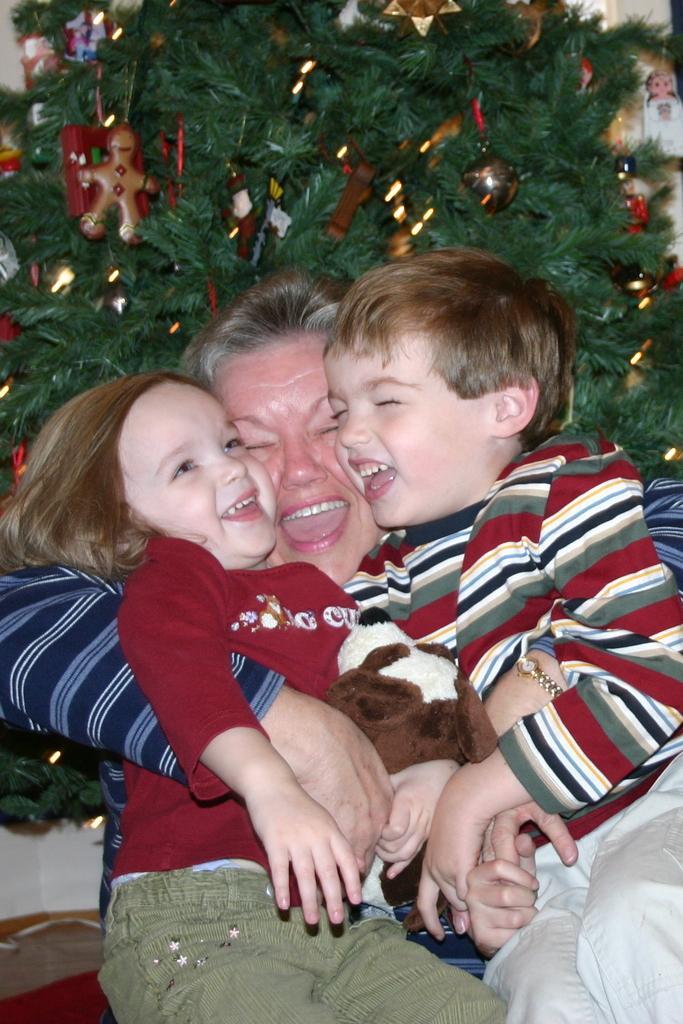Describe this image in one or two sentences. In the center of the image we can see a lady is sitting and holding the kids. In the background of the image we can see an Xmas tree with the decor. 